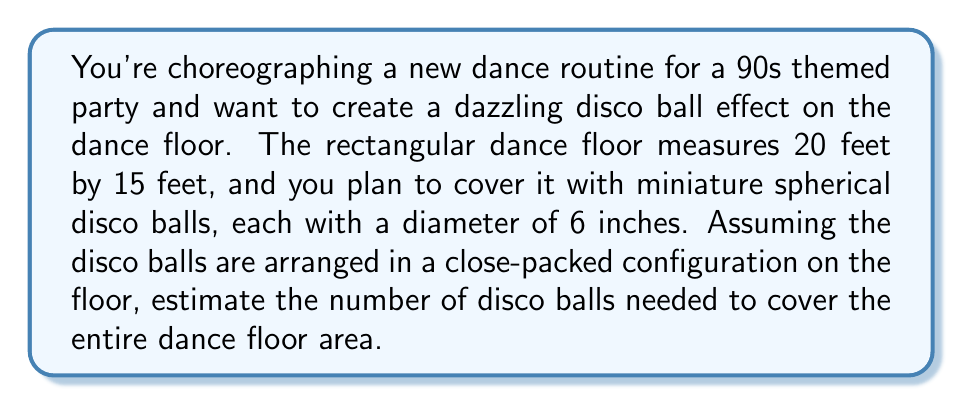Show me your answer to this math problem. Let's approach this step-by-step:

1) First, we need to convert all measurements to the same unit. Let's use inches:
   Dance floor: 20 feet × 15 feet = 240 inches × 180 inches
   Disco ball diameter: 6 inches

2) In a close-packed configuration, each disco ball occupies a hexagonal area. The area of this hexagon can be approximated by a square with side length equal to the ball's diameter:

   Area occupied by one ball ≈ $6^2 = 36$ square inches

3) Calculate the total area of the dance floor:
   
   $A_{floor} = 240 \times 180 = 43,200$ square inches

4) Estimate the number of disco balls needed:

   $N_{balls} = \frac{A_{floor}}{A_{ball}} = \frac{43,200}{36} = 1,200$

5) However, this estimate doesn't account for gaps between the balls or incomplete coverage at the edges. To ensure full coverage, we should round up and add a small buffer:

   $N_{balls} \approx 1,200 \times 1.1 = 1,320$

[asy]
unitsize(1cm);
draw((0,0)--(8,0)--(8,6)--(0,6)--cycle);
for(int i=0; i<=8; i+=1)
  for(int j=0; j<=6; j+=1)
    fill(circle((i,j),0.45), gray);
label("Dance floor (not to scale)", (4,-0.5));
[/asy]
Answer: Approximately 1,320 miniature disco balls would be needed to cover the dance floor. 